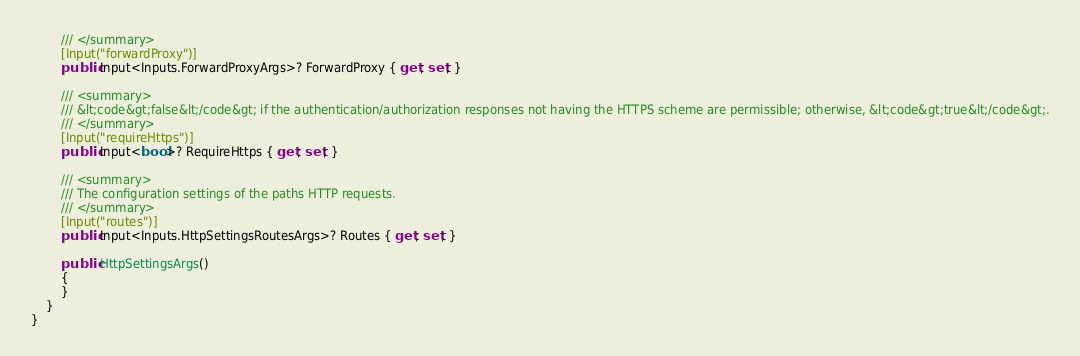Convert code to text. <code><loc_0><loc_0><loc_500><loc_500><_C#_>        /// </summary>
        [Input("forwardProxy")]
        public Input<Inputs.ForwardProxyArgs>? ForwardProxy { get; set; }

        /// <summary>
        /// &lt;code&gt;false&lt;/code&gt; if the authentication/authorization responses not having the HTTPS scheme are permissible; otherwise, &lt;code&gt;true&lt;/code&gt;.
        /// </summary>
        [Input("requireHttps")]
        public Input<bool>? RequireHttps { get; set; }

        /// <summary>
        /// The configuration settings of the paths HTTP requests.
        /// </summary>
        [Input("routes")]
        public Input<Inputs.HttpSettingsRoutesArgs>? Routes { get; set; }

        public HttpSettingsArgs()
        {
        }
    }
}
</code> 